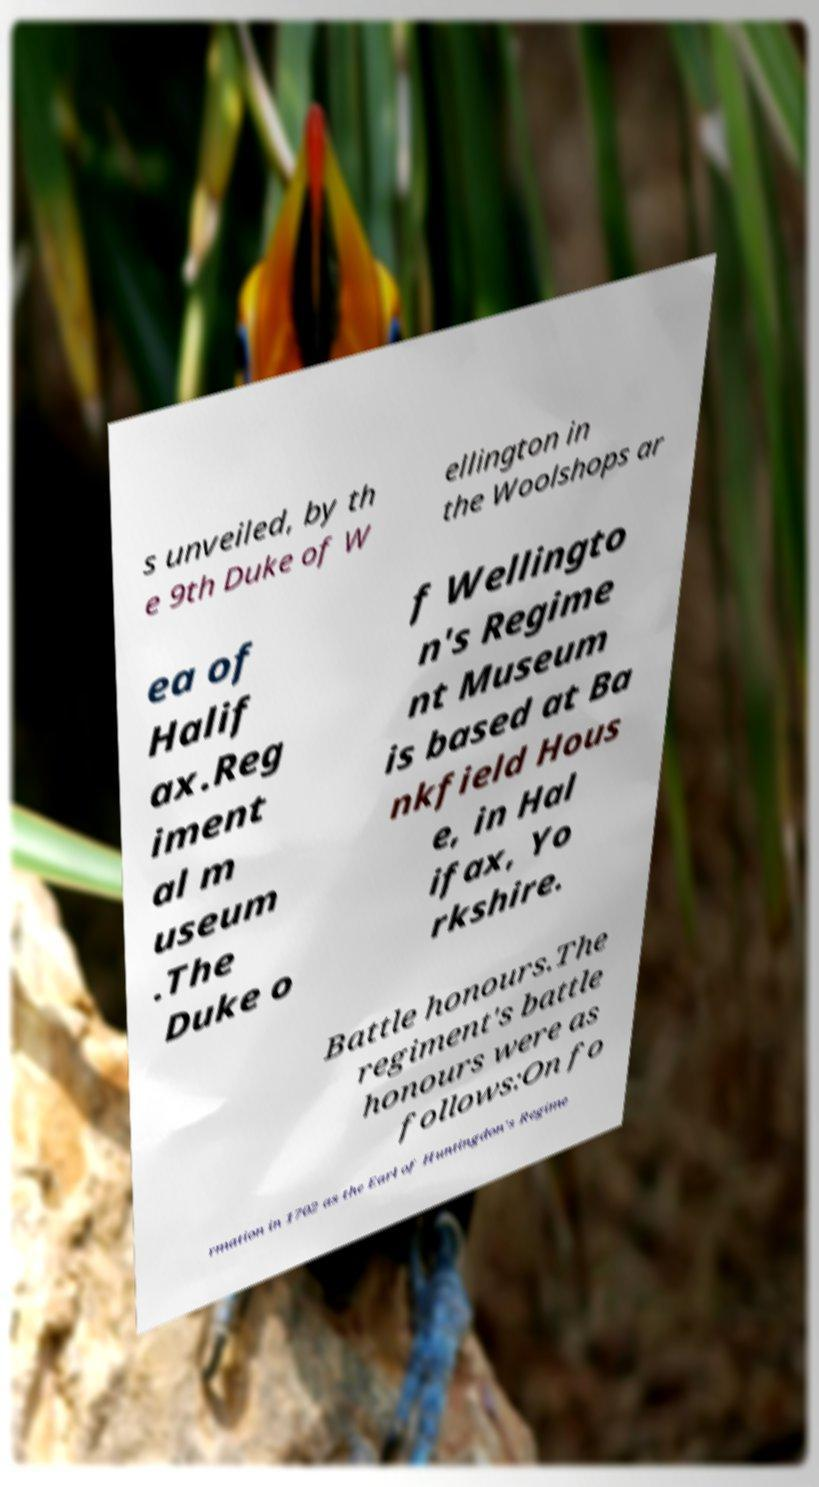Could you extract and type out the text from this image? s unveiled, by th e 9th Duke of W ellington in the Woolshops ar ea of Halif ax.Reg iment al m useum .The Duke o f Wellingto n's Regime nt Museum is based at Ba nkfield Hous e, in Hal ifax, Yo rkshire. Battle honours.The regiment's battle honours were as follows:On fo rmation in 1702 as the Earl of Huntingdon's Regime 